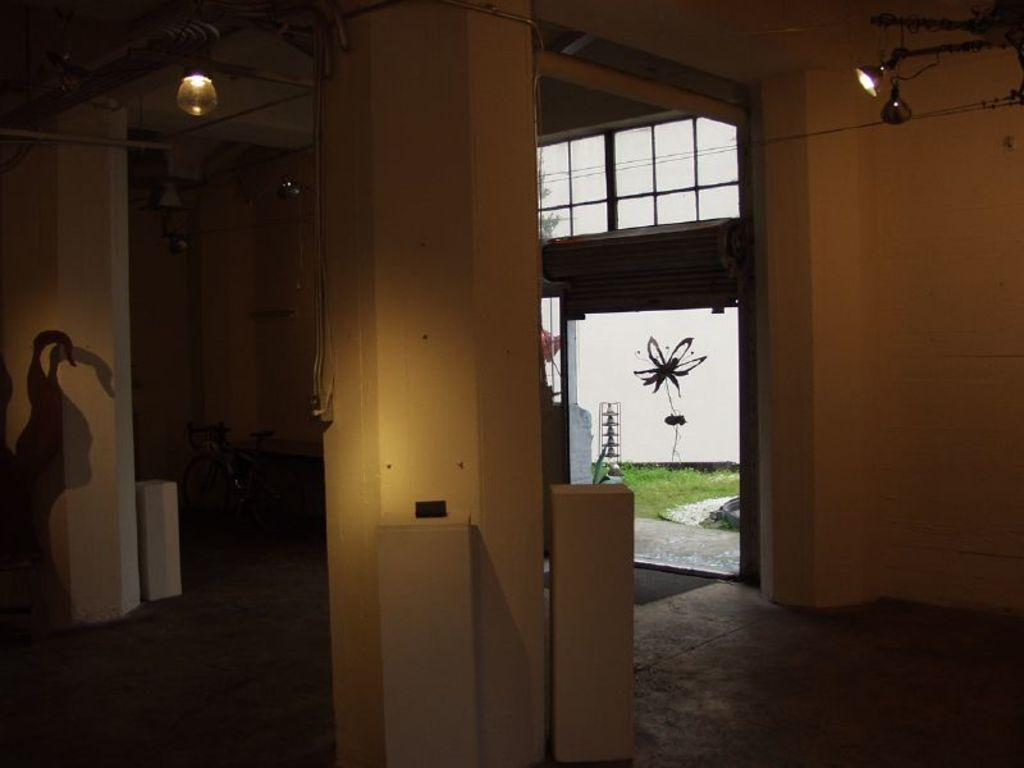What type of view is shown in the image? The image shows the inner view of a building. What can be seen inside the building? There are pipelines, a bicycle, and electric lights visible inside the building. What is the natural environment like outside the building? Outside the building, there are plants and grass visible, and cables are also present. How many needles are being used to sort the matches in the image? There are no needles or matches present in the image. 